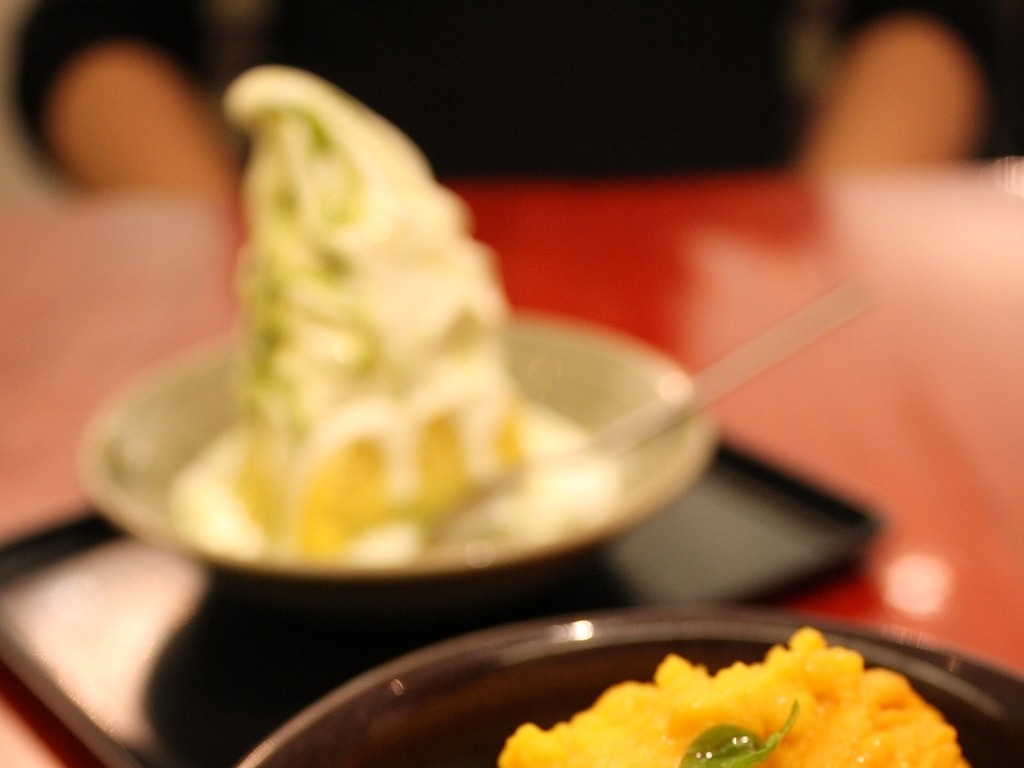What kind of flavors or textures might the foods in the image have? The soft serve ice cream likely has a smooth and creamy texture, with a subtle sweetness coupled with a hint of matcha or other flavors suggested by its green color. The orange mash on the plate, possibly pumpkin or sweet potato, suggests a denser texture with earthy sweetness, enhanced by the freshness of the green garnish. 